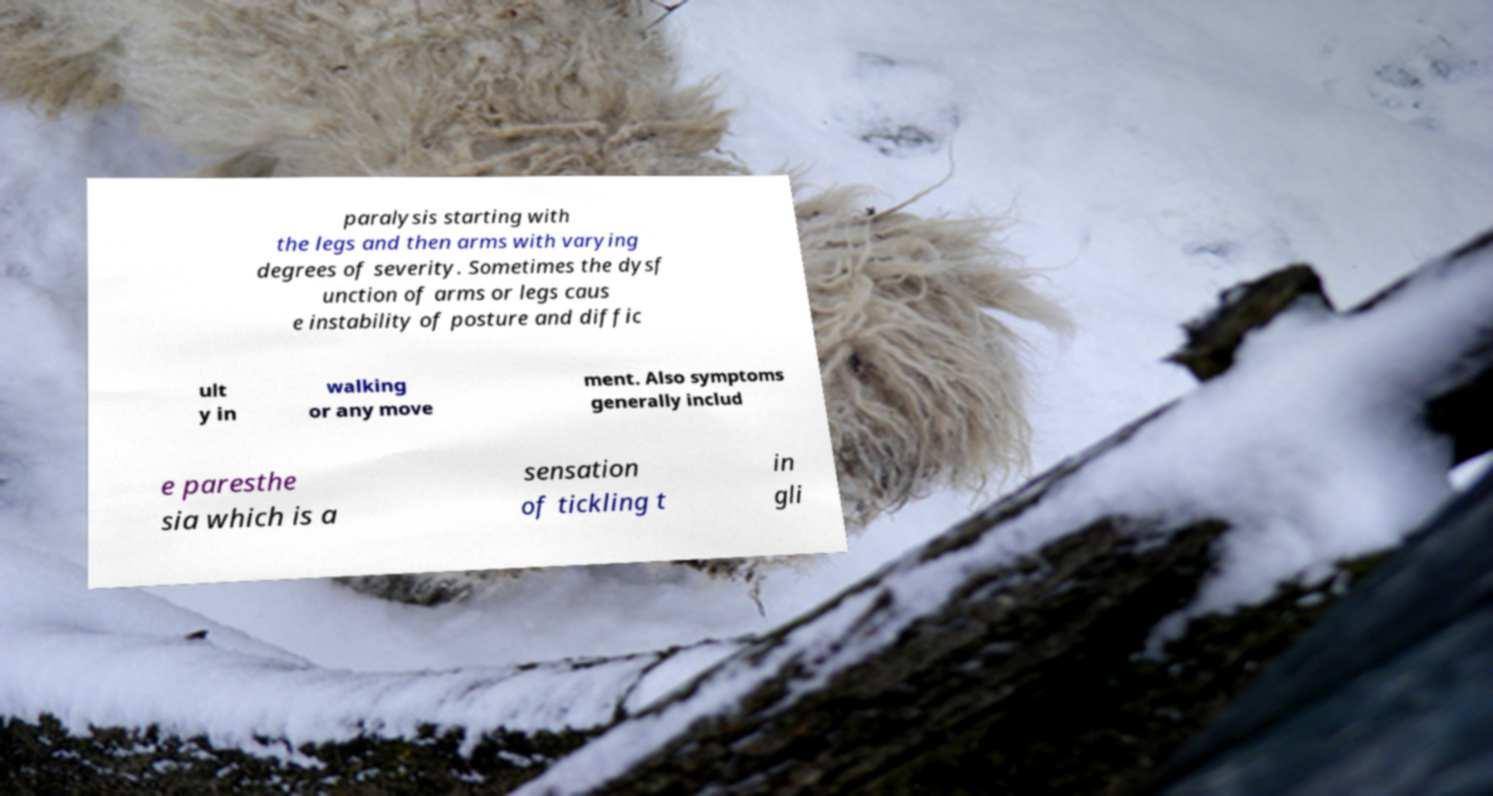I need the written content from this picture converted into text. Can you do that? paralysis starting with the legs and then arms with varying degrees of severity. Sometimes the dysf unction of arms or legs caus e instability of posture and diffic ult y in walking or any move ment. Also symptoms generally includ e paresthe sia which is a sensation of tickling t in gli 